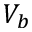Convert formula to latex. <formula><loc_0><loc_0><loc_500><loc_500>V _ { b }</formula> 